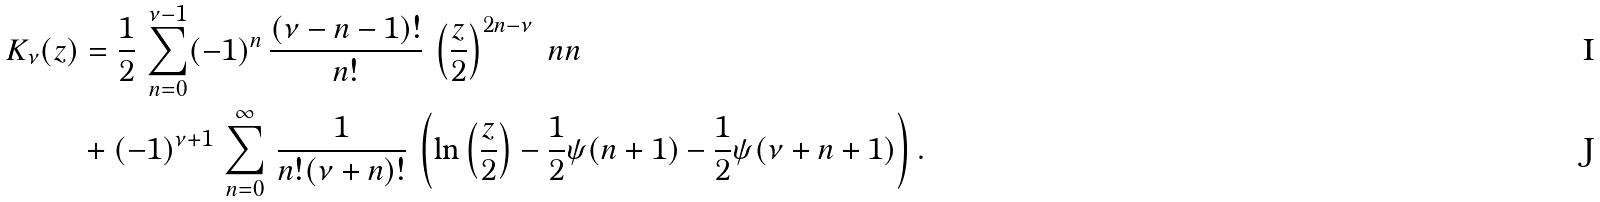<formula> <loc_0><loc_0><loc_500><loc_500>K _ { \nu } ( z ) & = \frac { 1 } { 2 } \, \sum _ { n = 0 } ^ { \nu - 1 } ( - 1 ) ^ { n } \, \frac { ( \nu - n - 1 ) ! } { n ! } \, \left ( \frac { z } { 2 } \right ) ^ { 2 n - \nu } \ n n \\ & + ( - 1 ) ^ { \nu + 1 } \, \sum _ { n = 0 } ^ { \infty } \, \frac { 1 } { n ! ( \nu + n ) ! } \, \left ( \ln \left ( \frac { z } { 2 } \right ) - \frac { 1 } { 2 } \psi ( n + 1 ) - \frac { 1 } { 2 } \psi ( \nu + n + 1 ) \right ) .</formula> 